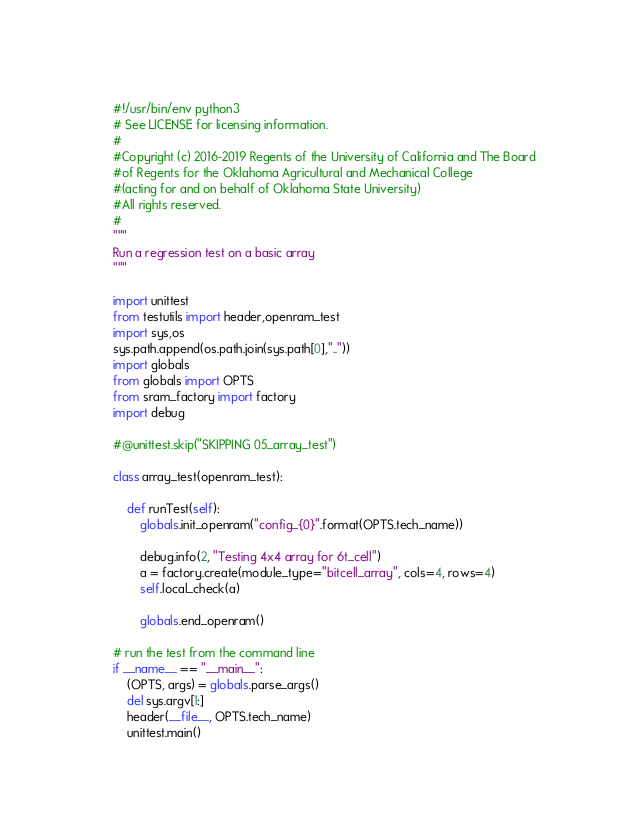Convert code to text. <code><loc_0><loc_0><loc_500><loc_500><_Python_>#!/usr/bin/env python3
# See LICENSE for licensing information.
#
#Copyright (c) 2016-2019 Regents of the University of California and The Board
#of Regents for the Oklahoma Agricultural and Mechanical College
#(acting for and on behalf of Oklahoma State University)
#All rights reserved.
#
"""
Run a regression test on a basic array
"""

import unittest
from testutils import header,openram_test
import sys,os
sys.path.append(os.path.join(sys.path[0],".."))
import globals
from globals import OPTS
from sram_factory import factory
import debug

#@unittest.skip("SKIPPING 05_array_test")

class array_test(openram_test):

    def runTest(self):
        globals.init_openram("config_{0}".format(OPTS.tech_name))

        debug.info(2, "Testing 4x4 array for 6t_cell")
        a = factory.create(module_type="bitcell_array", cols=4, rows=4)
        self.local_check(a)

        globals.end_openram()

# run the test from the command line
if __name__ == "__main__":
    (OPTS, args) = globals.parse_args()
    del sys.argv[1:]
    header(__file__, OPTS.tech_name)
    unittest.main()
</code> 